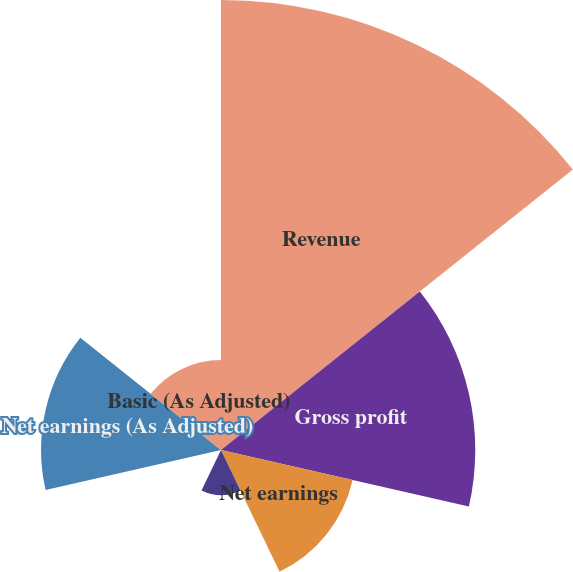Convert chart to OTSL. <chart><loc_0><loc_0><loc_500><loc_500><pie_chart><fcel>Revenue<fcel>Gross profit<fcel>Net earnings<fcel>Basic<fcel>Diluted<fcel>Net earnings (As Adjusted)<fcel>Basic (As Adjusted)<nl><fcel>38.99%<fcel>22.03%<fcel>11.7%<fcel>3.9%<fcel>0.0%<fcel>15.59%<fcel>7.8%<nl></chart> 